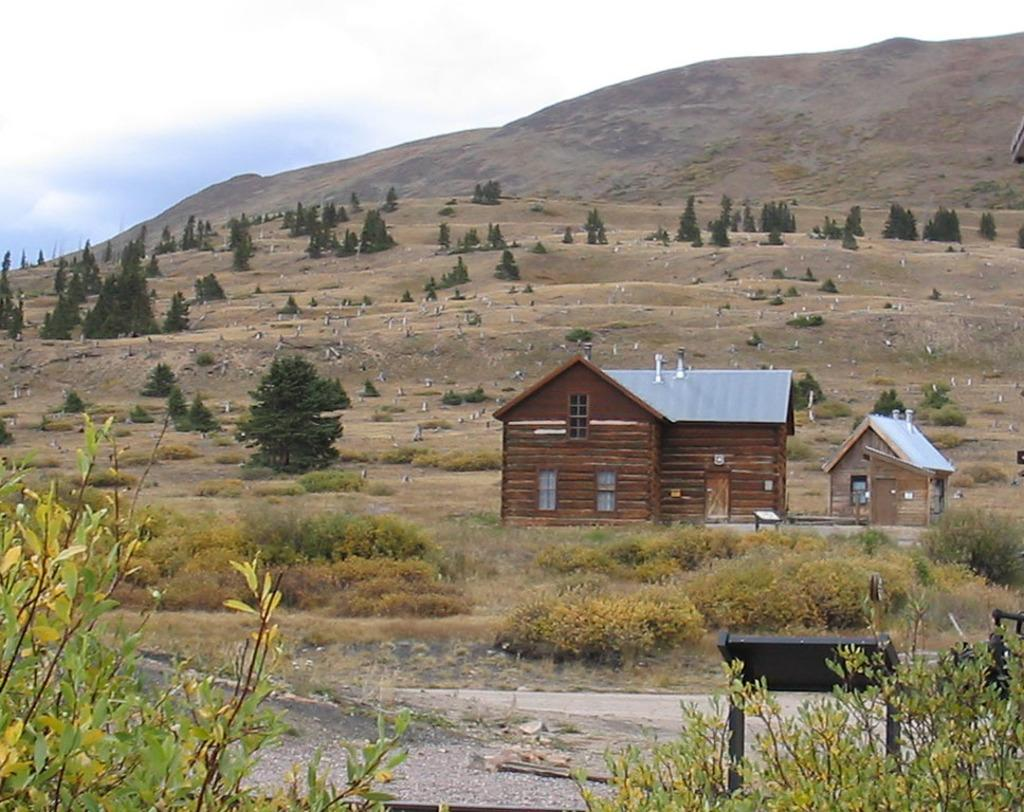What type of structure is visible in the image? There is a house in the image. What other natural elements can be seen in the image? There are trees and mountains in the image. What is visible at the top of the image? The sky is visible at the top of the image. What can be observed in the sky? Clouds are present in the sky. Where is the park located in the image? There is no park present in the image. What type of power source is visible in the image? There is no power source visible in the image. 